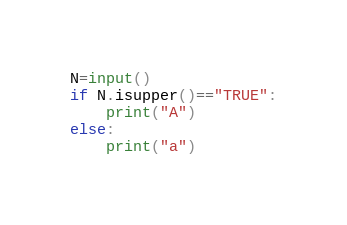<code> <loc_0><loc_0><loc_500><loc_500><_Python_>N=input()
if N.isupper()=="TRUE":
    print("A")
else:
    print("a")</code> 